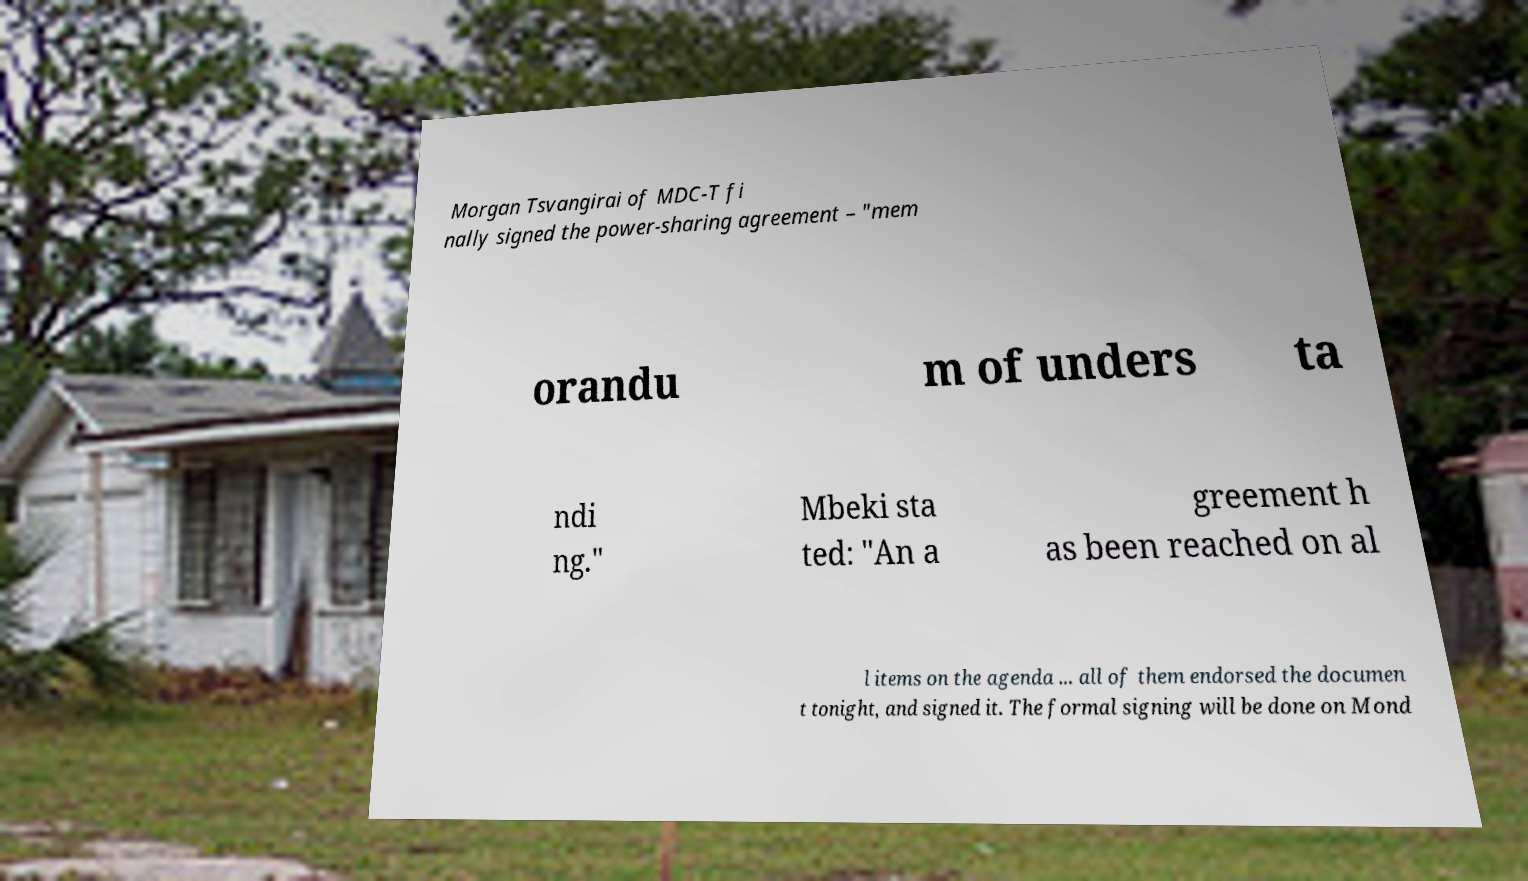Could you assist in decoding the text presented in this image and type it out clearly? Morgan Tsvangirai of MDC-T fi nally signed the power-sharing agreement – "mem orandu m of unders ta ndi ng." Mbeki sta ted: "An a greement h as been reached on al l items on the agenda ... all of them endorsed the documen t tonight, and signed it. The formal signing will be done on Mond 